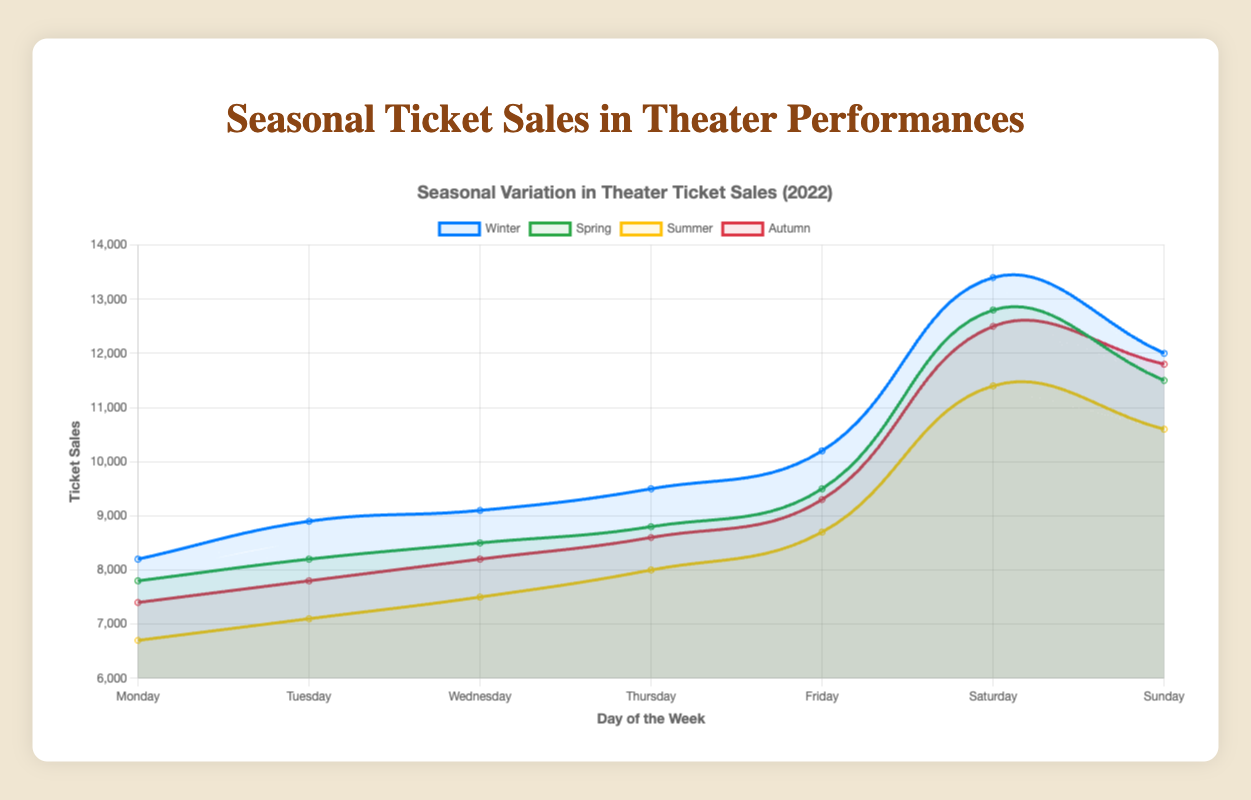What is the highest ticket sales recorded on a Saturday? Looking at the breakdown by day and season, the highest ticket sales on a Saturday occur in Winter. The ticket sales are 13,400.
Answer: 13,400 In which season are Tuesday's ticket sales the lowest? Compare the ticket sales by season for each Tuesday. Winter has 8,900, Spring has 8,200, Summer has 7,100, and Autumn has 7,800. The lowest is in Summer.
Answer: Summer Which day of the week shows the most substantial increase in ticket sales from Winter to Summer? Starting with Monday, ticket sales drop considerably. For Tuesday, the sales also decline. For Wednesday, there is a drop. For Thursday, the trend continues to decrease. This continues similarly for Friday, Saturday, and Sunday with Winter having higher sales than Summer. The decline is not an increase.
Answer: None (most days decrease from Winter to Summer) What is the average ticket sales for Fridays across all seasons? Sum the ticket sales for Fridays from the four seasons: 10,200 (Winter) + 9,500 (Spring) + 8,700 (Summer) + 9,300 (Autumn) = 37,700. Then, divide this sum by 4 (the number of seasons): 37,700 / 4 = 9,425.
Answer: 9,425 What pattern is observed in Saturday ticket sales across the seasons? Evaluate Saturday ticket sales: Winter (13,400), Spring (12,800), Summer (11,400), Autumn (12,500). Notice they are highest during Winter and gradually decrease into Spring, lower in Summer, and rise slightly in Autumn.
Answer: Decreasing trend until summer and slight rise in autumn Which season has the most consistent ticket sales across the weekdays? Review the variation in ticket sales for each season. Winter and Autumn exhibit more variation. Spring shows gradual increases and decreases, suggesting more consistency. Summer also shows gradual variation but is more spaced than Spring.
Answer: Spring Compare the ticket sales on Sundays between Winter and Autumn. Which is higher? Compare Sunday ticket sales: Winter has 12,000 and Autumn has 11,800. The ticket sales are higher in Winter.
Answer: Winter On which weekday is the difference in ticket sales between Winter and Spring the greatest? Find the differences for each day: Monday (8200-7800=400), Tuesday (8900-8200=700), Wednesday (9100-8500=600), Thursday (9500-8800=700), Friday (10200-9500=700), Saturday (13400-12800=600), Sunday (12000-11500=500). The greatest difference is on Friday with 700.
Answer: Friday 